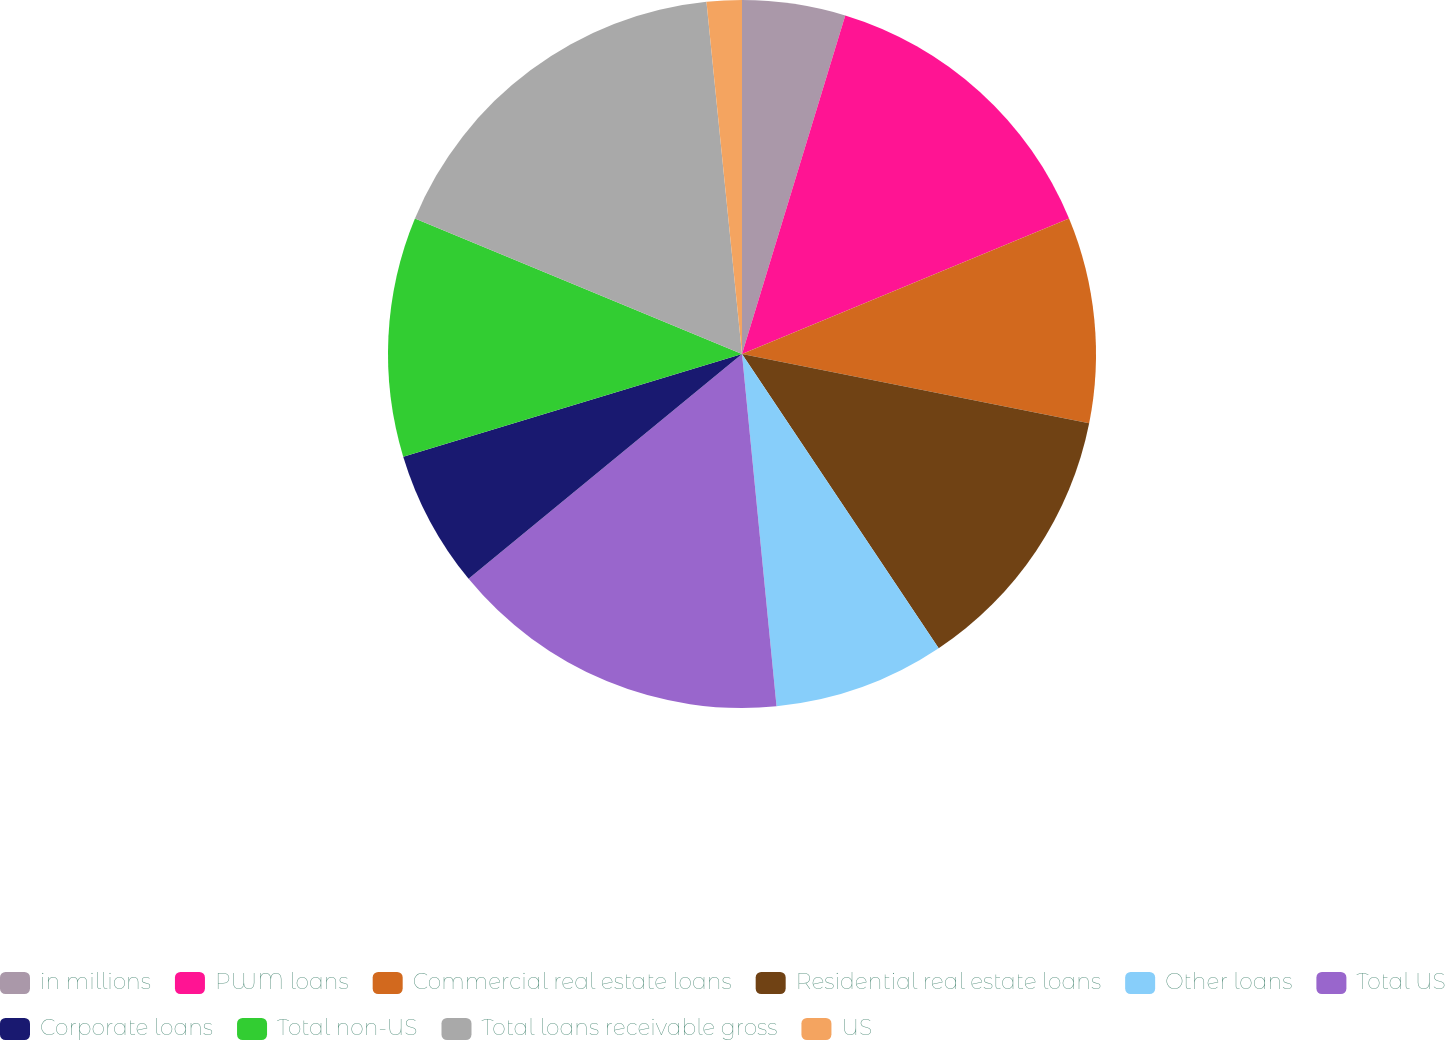Convert chart. <chart><loc_0><loc_0><loc_500><loc_500><pie_chart><fcel>in millions<fcel>PWM loans<fcel>Commercial real estate loans<fcel>Residential real estate loans<fcel>Other loans<fcel>Total US<fcel>Corporate loans<fcel>Total non-US<fcel>Total loans receivable gross<fcel>US<nl><fcel>4.71%<fcel>14.04%<fcel>9.38%<fcel>12.49%<fcel>7.82%<fcel>15.6%<fcel>6.27%<fcel>10.93%<fcel>17.15%<fcel>1.6%<nl></chart> 